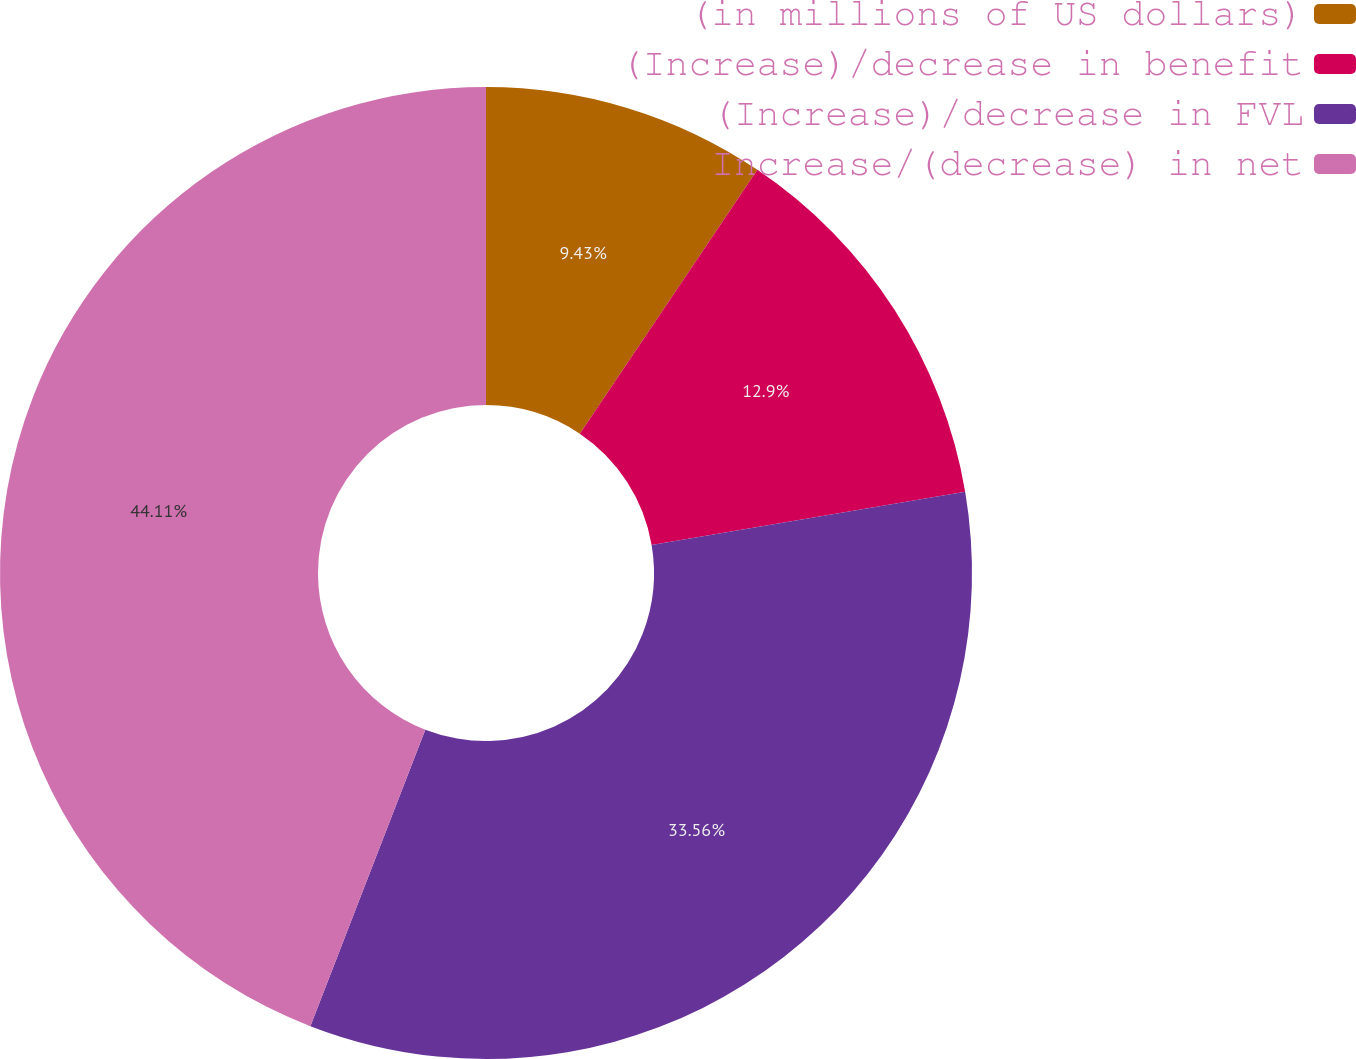Convert chart. <chart><loc_0><loc_0><loc_500><loc_500><pie_chart><fcel>(in millions of US dollars)<fcel>(Increase)/decrease in benefit<fcel>(Increase)/decrease in FVL<fcel>Increase/(decrease) in net<nl><fcel>9.43%<fcel>12.9%<fcel>33.56%<fcel>44.12%<nl></chart> 